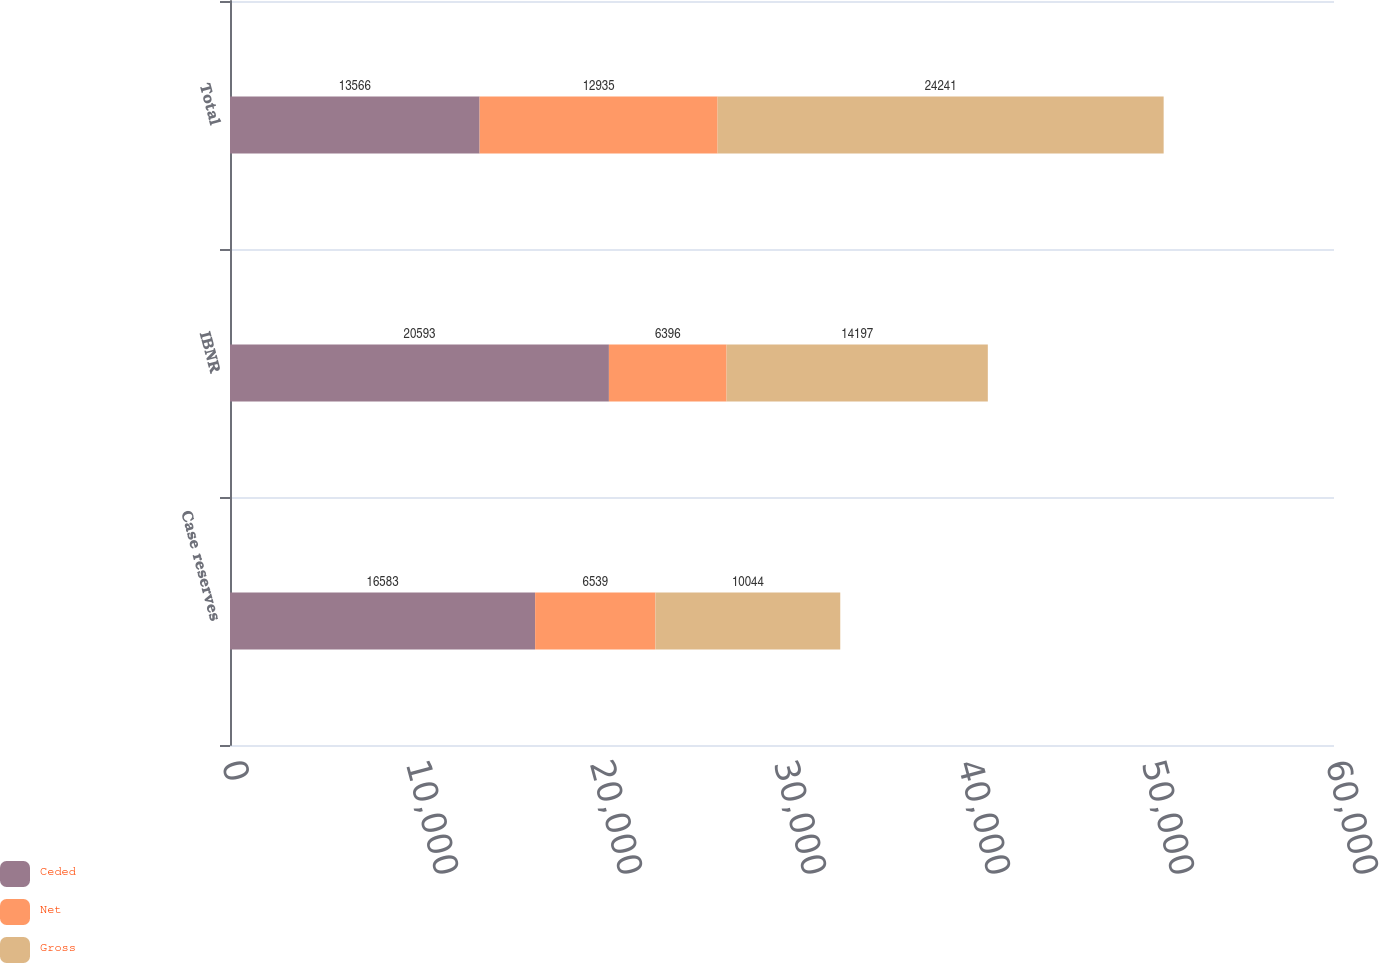Convert chart to OTSL. <chart><loc_0><loc_0><loc_500><loc_500><stacked_bar_chart><ecel><fcel>Case reserves<fcel>IBNR<fcel>Total<nl><fcel>Ceded<fcel>16583<fcel>20593<fcel>13566<nl><fcel>Net<fcel>6539<fcel>6396<fcel>12935<nl><fcel>Gross<fcel>10044<fcel>14197<fcel>24241<nl></chart> 